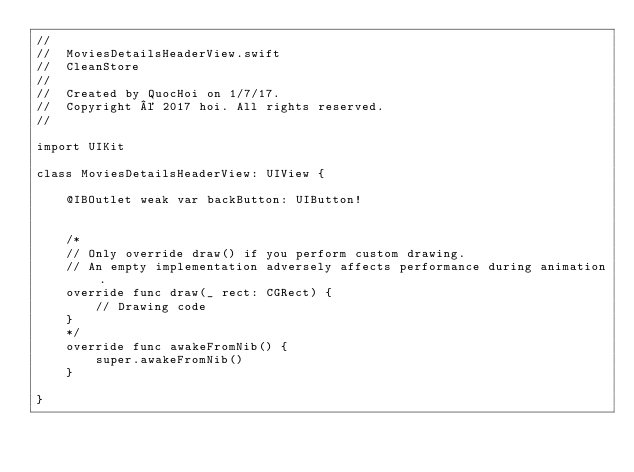Convert code to text. <code><loc_0><loc_0><loc_500><loc_500><_Swift_>//
//  MoviesDetailsHeaderView.swift
//  CleanStore
//
//  Created by QuocHoi on 1/7/17.
//  Copyright © 2017 hoi. All rights reserved.
//

import UIKit

class MoviesDetailsHeaderView: UIView {
    
    @IBOutlet weak var backButton: UIButton!
    

    /*
    // Only override draw() if you perform custom drawing.
    // An empty implementation adversely affects performance during animation.
    override func draw(_ rect: CGRect) {
        // Drawing code
    }
    */
    override func awakeFromNib() {
        super.awakeFromNib()
    }

}
</code> 